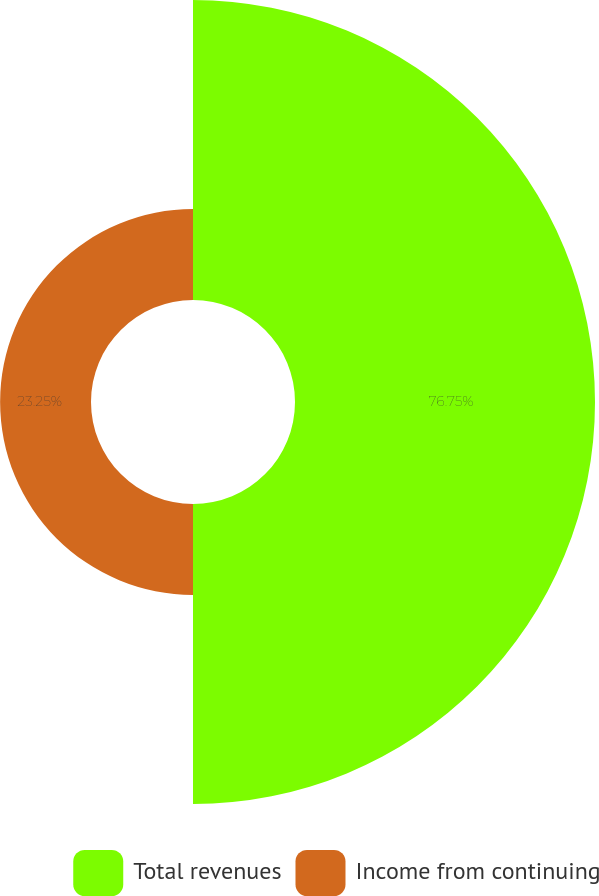Convert chart to OTSL. <chart><loc_0><loc_0><loc_500><loc_500><pie_chart><fcel>Total revenues<fcel>Income from continuing<nl><fcel>76.75%<fcel>23.25%<nl></chart> 